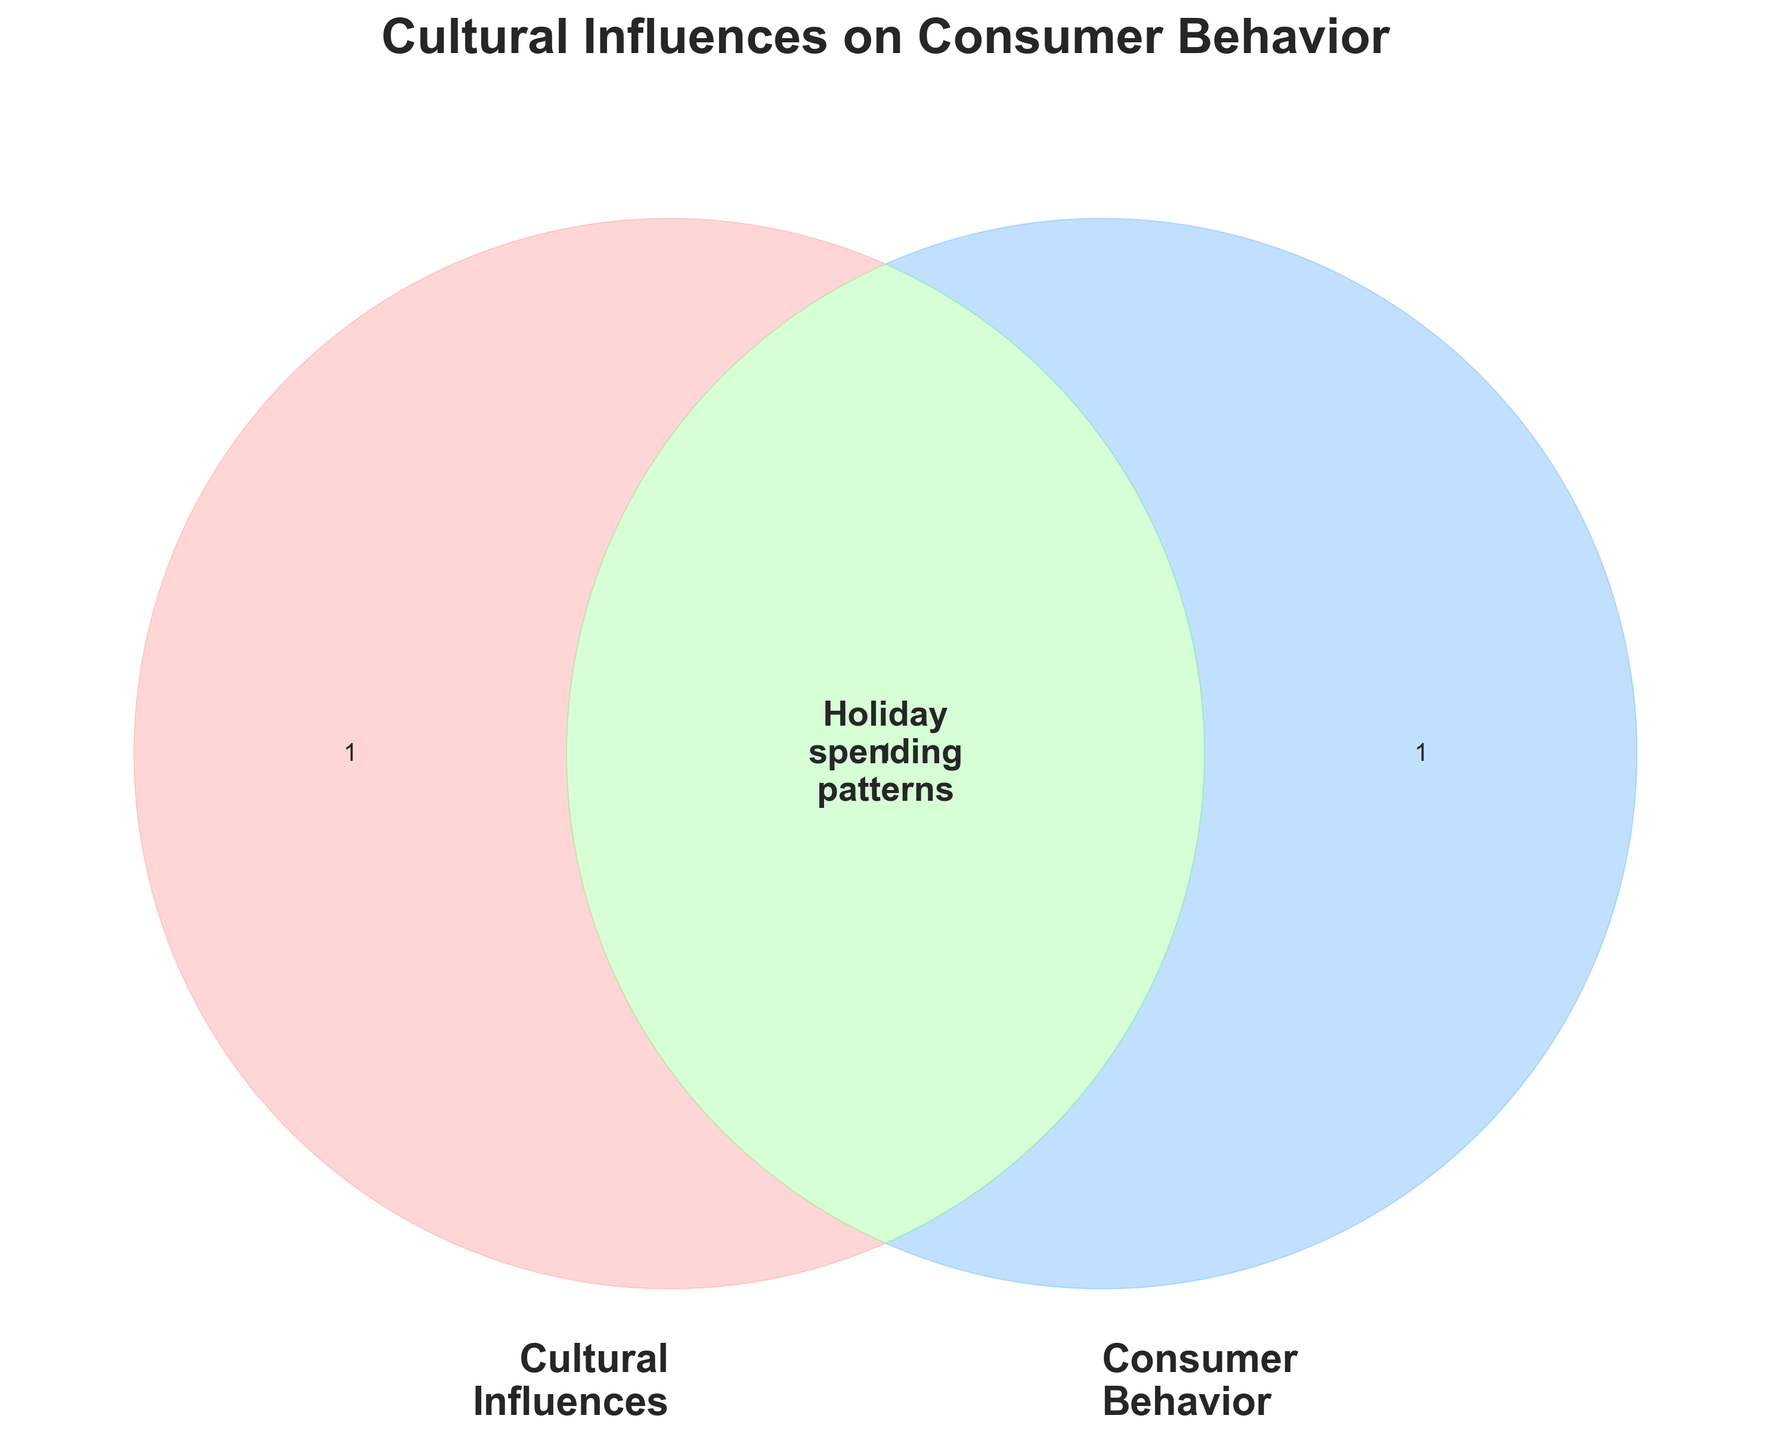What is the title of the figure? The title is displayed at the top of the Venn diagram in bold and large font. It reads "Cultural Influences on Consumer Behavior"
Answer: Cultural Influences on Consumer Behavior What are the labels for the two circles in the Venn diagram? Each circle in the Venn diagram has a label. The left circle is labeled “Cultural Influences” and the right circle is labeled “Consumer Behavior”
Answer: Cultural Influences, Consumer Behavior What color is used for the circle labeled 'Cultural Influences'? The color of the 'Cultural Influences' circle is visible as a soft red shade.
Answer: Soft red What is the color of the 'Consumer Behavior' circle? The 'Consumer Behavior' circle is colored in a light blue shade.
Answer: Light blue What concept is at the intersection of 'Cultural Influences' and 'Consumer Behavior'? At the center of the intersection of the two circles, it is annotated with the text "Holiday spending patterns"
Answer: Holiday spending patterns What is the background style used in the figure? The background has a dark theme, indicated by the smooth and muted colors and shaded areas.
Answer: Dark theme What is the significance of the intersection area in the Venn diagram? The intersection area represents the concept that overlaps between cultural influences and consumer behavior, specified as "Holiday spending patterns" in this case.
Answer: Overlap between cultural influences and consumer behavior 